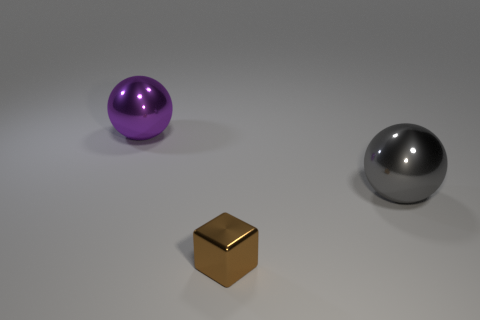Add 3 big purple balls. How many objects exist? 6 Subtract all blocks. How many objects are left? 2 Subtract 1 brown blocks. How many objects are left? 2 Subtract all large gray things. Subtract all small brown matte balls. How many objects are left? 2 Add 3 brown blocks. How many brown blocks are left? 4 Add 3 purple metal spheres. How many purple metal spheres exist? 4 